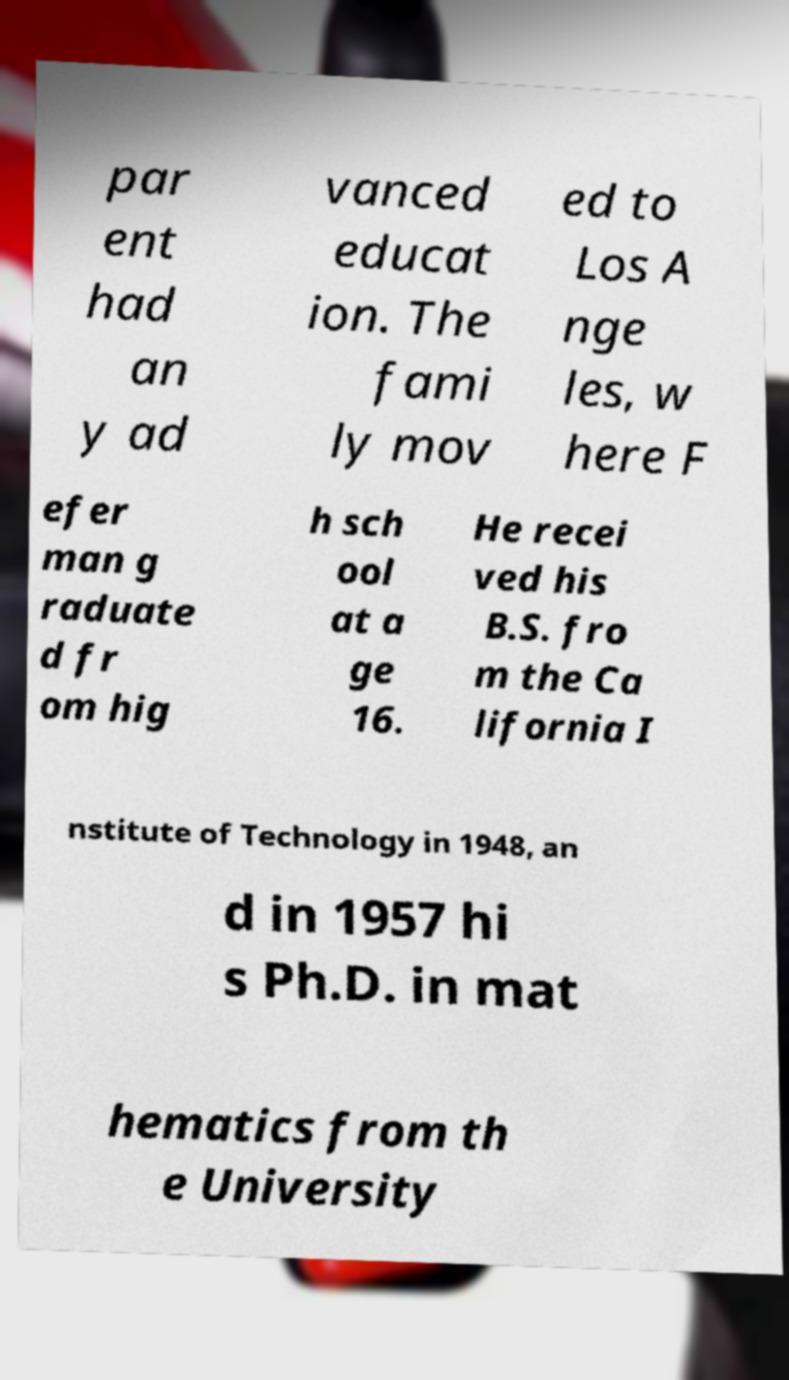Please identify and transcribe the text found in this image. par ent had an y ad vanced educat ion. The fami ly mov ed to Los A nge les, w here F efer man g raduate d fr om hig h sch ool at a ge 16. He recei ved his B.S. fro m the Ca lifornia I nstitute of Technology in 1948, an d in 1957 hi s Ph.D. in mat hematics from th e University 